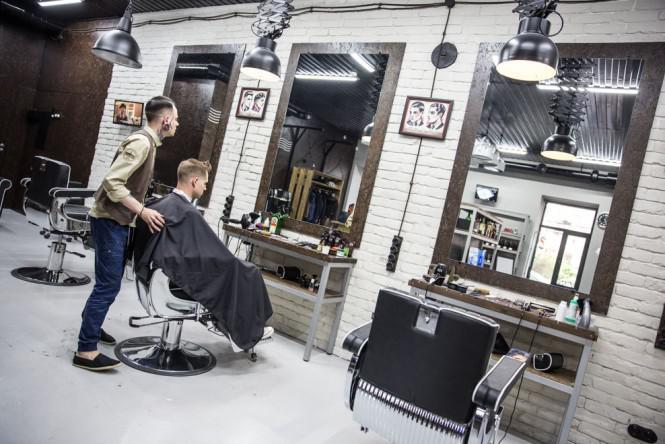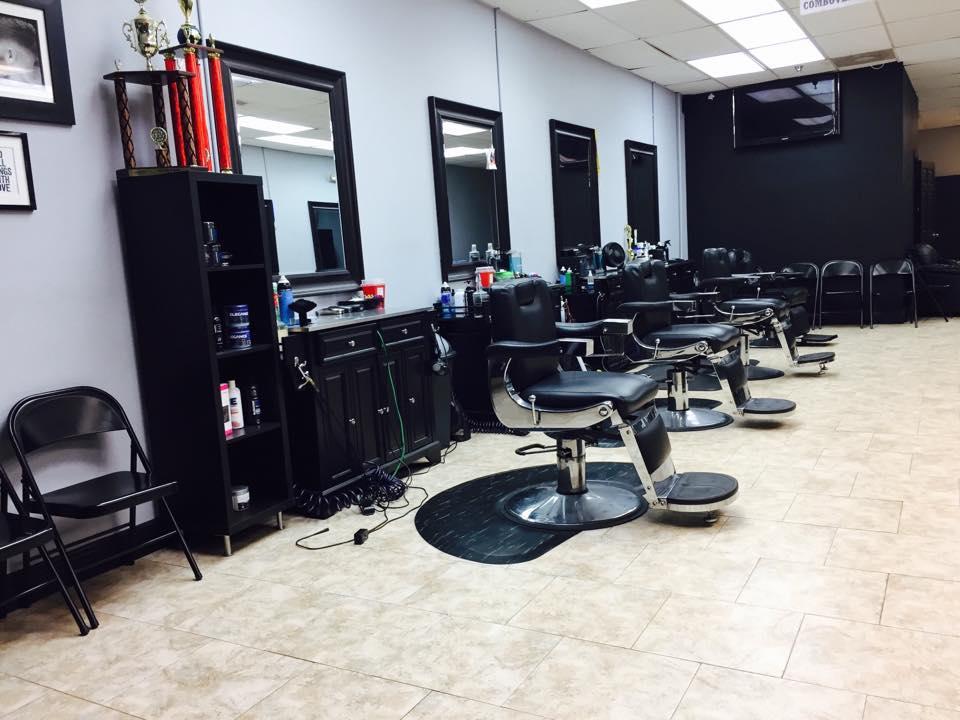The first image is the image on the left, the second image is the image on the right. Given the left and right images, does the statement "A barber is standing behind a client who is sitting." hold true? Answer yes or no. Yes. 